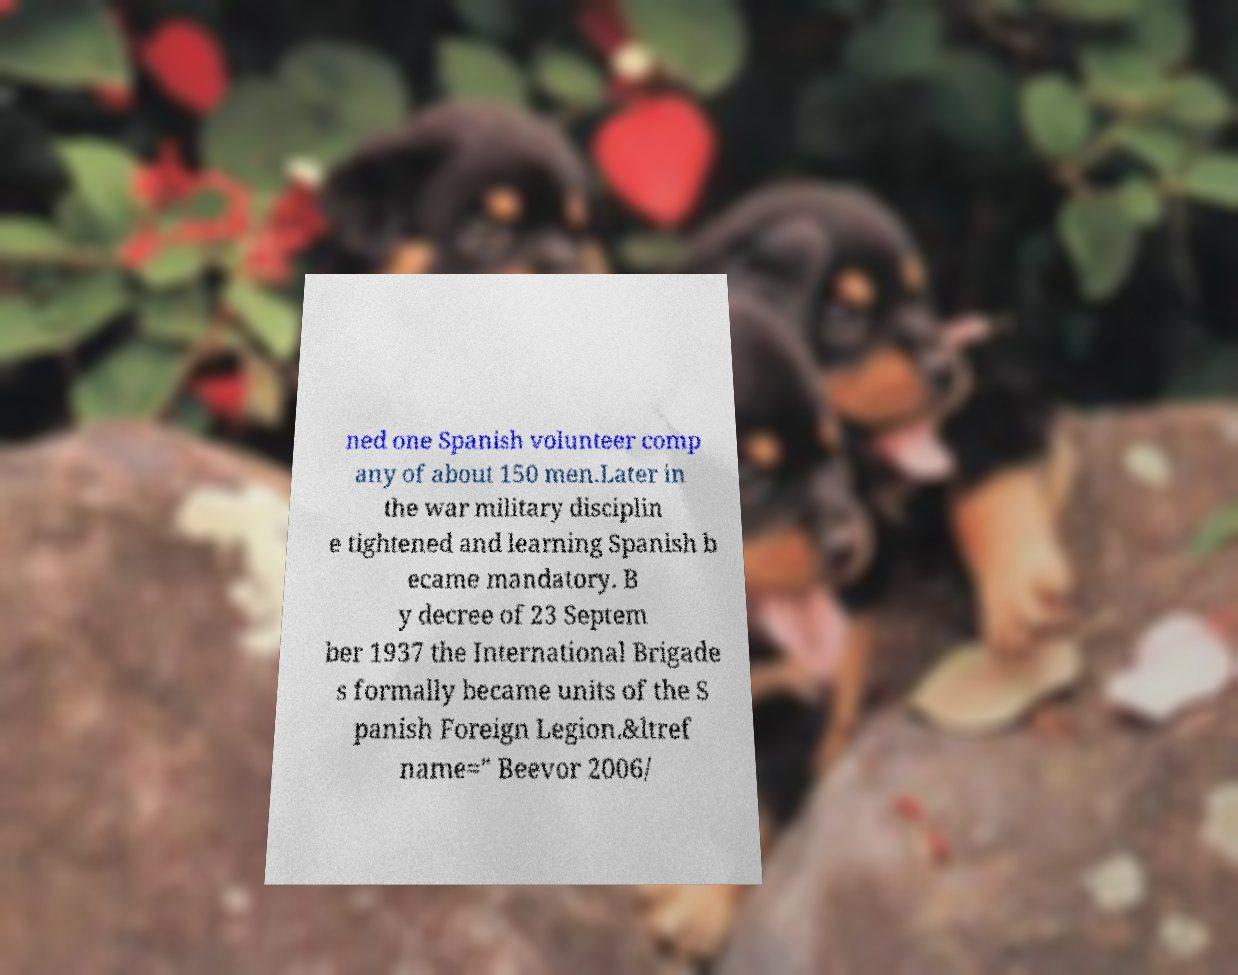Can you accurately transcribe the text from the provided image for me? ned one Spanish volunteer comp any of about 150 men.Later in the war military disciplin e tightened and learning Spanish b ecame mandatory. B y decree of 23 Septem ber 1937 the International Brigade s formally became units of the S panish Foreign Legion.&ltref name=" Beevor 2006/ 